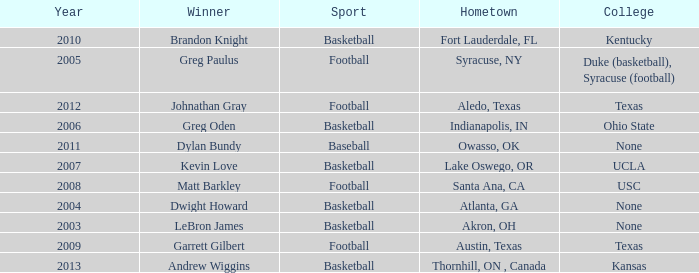What is Hometown, when Sport is "Basketball", and when Winner is "Dwight Howard"? Atlanta, GA. 